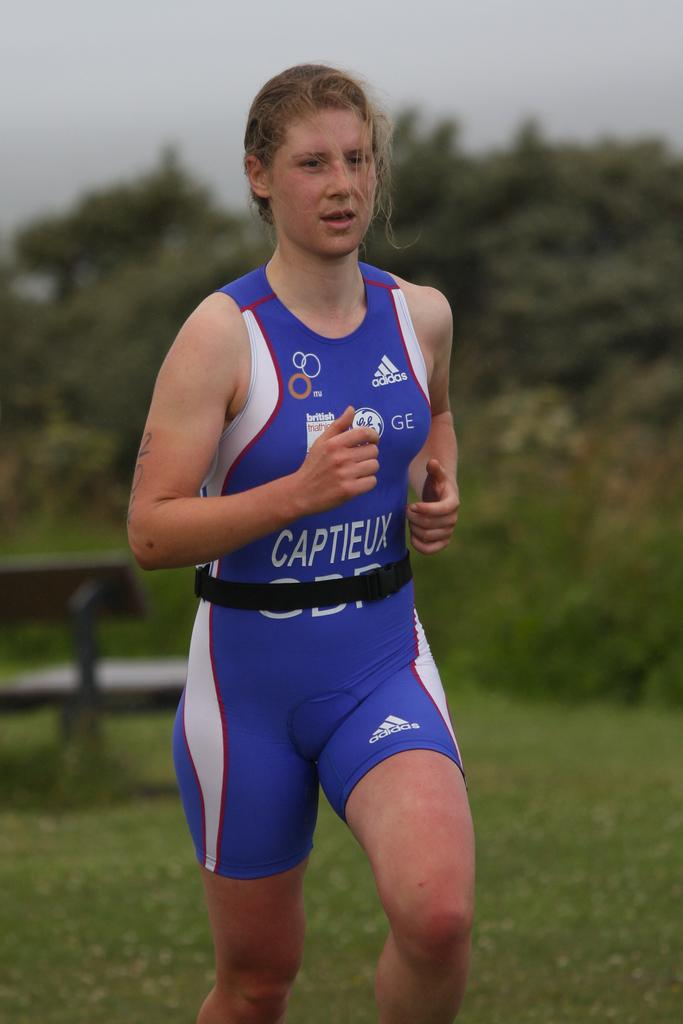<image>
Provide a brief description of the given image. A woman in an adidas uniform wears a black belt while jogging. 